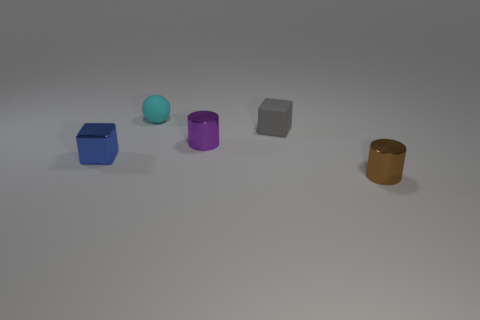Add 5 brown metal cylinders. How many objects exist? 10 Subtract all blocks. How many objects are left? 3 Subtract 1 blocks. How many blocks are left? 1 Subtract all tiny brown shiny things. Subtract all tiny brown shiny balls. How many objects are left? 4 Add 2 purple shiny cylinders. How many purple shiny cylinders are left? 3 Add 5 small metallic cylinders. How many small metallic cylinders exist? 7 Subtract 0 purple spheres. How many objects are left? 5 Subtract all green spheres. Subtract all purple cubes. How many spheres are left? 1 